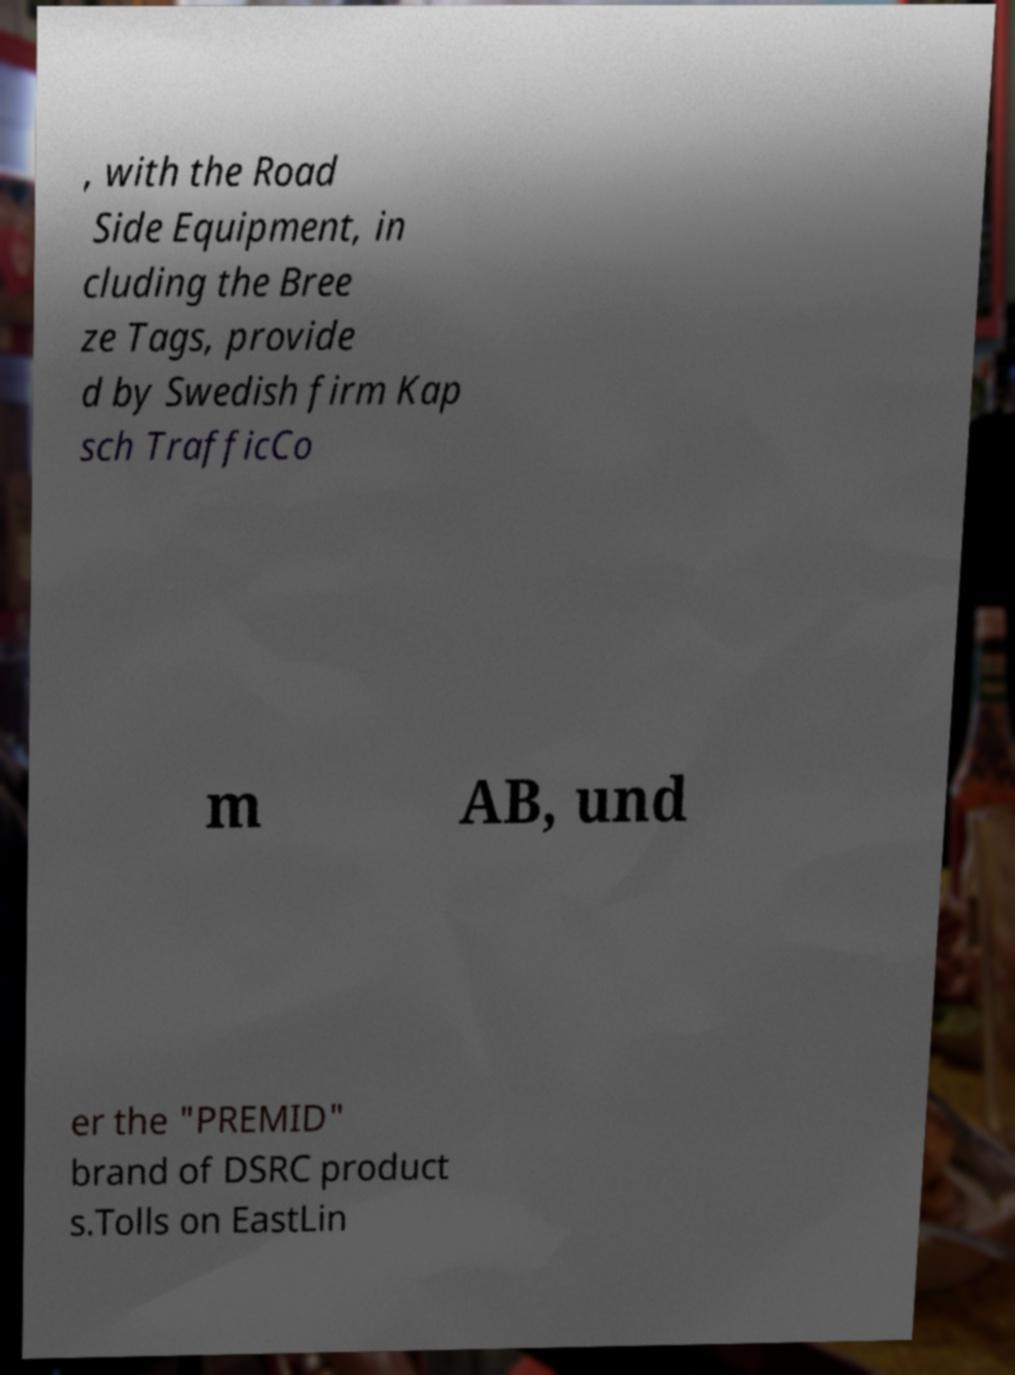Could you extract and type out the text from this image? , with the Road Side Equipment, in cluding the Bree ze Tags, provide d by Swedish firm Kap sch TrafficCo m AB, und er the "PREMID" brand of DSRC product s.Tolls on EastLin 